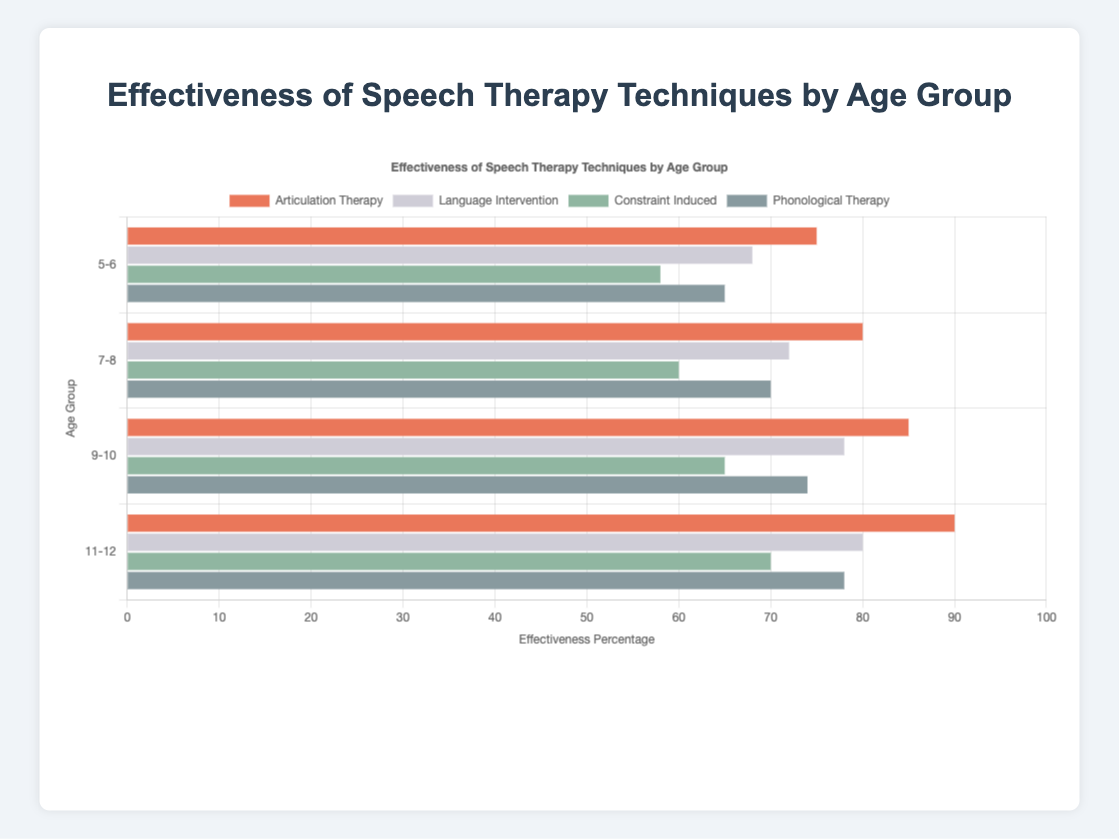Which age group demonstrates the highest effectiveness for Articulation Therapy? To determine the age group with the highest effectiveness for Articulation Therapy, look at the bars corresponding to Articulation Therapy for each age group and find the one with the greatest length.
Answer: 11-12 How much more effective is Phonological Therapy than Constraint Induced therapy in the 5-6 age group? Identify the effectiveness percentages for both Phonological Therapy and Constraint Induced therapy in the 5-6 age group. Subtract the effectiveness percentage of Constraint Induced therapy from that of Phonological Therapy (65 - 58).
Answer: 7 What is the average effectiveness of Language Intervention across all age groups? Extract the effectiveness percentages of Language Intervention for all age groups: 68, 72, 78, 80. Sum these values and then divide by the number of age groups ((68 + 72 + 78 + 80) / 4).
Answer: 74.5 Which therapy technique has the lowest effectiveness in the 9-10 age group? Compare the effectiveness percentages of all therapy techniques in the 9-10 age group. The therapy with the smallest percentage is the one with the lowest effectiveness.
Answer: Constraint Induced What is the difference in effectiveness of Articulation Therapy between the 7-8 age group and the 9-10 age group? Locate the effectiveness percentages for Articulation Therapy for the 7-8 and 9-10 age groups. Subtract the percentage for the 7-8 age group from the percentage for the 9-10 age group (85 - 80).
Answer: 5 Which age group shows a greater improvement in Articulation Therapy effectiveness from the previous age group, the 7-8 age group or the 9-10 age group? Calculate the difference in effectiveness for Articulation Therapy between the 5-6 and 7-8 age group (80 - 75) and between the 7-8 and 9-10 age group (85 - 80). Compare the two results to determine the greater improvement.
Answer: 7-8 How does the effectiveness of Constraint Induced therapy compare across all age groups? Review the bars for Constraint Induced therapy in all age groups and observe the percentages: 58, 60, 65, 70. This shows a progressive increase in effectiveness with age.
Answer: Increases with age Which therapy technique shows the highest percentage difference in effectiveness between the youngest (5-6) and the oldest (11-12) age groups? Calculate the percentage differences for each therapy technique between the 5-6 and 11-12 age groups: 
- Articulation Therapy: 90 - 75 = 15
- Language Intervention: 80 - 68 = 12
- Constraint Induced: 70 - 58 = 12
- Phonological Therapy: 78 - 65 = 13
The technique with the highest difference is Articulation Therapy.
Answer: Articulation Therapy 